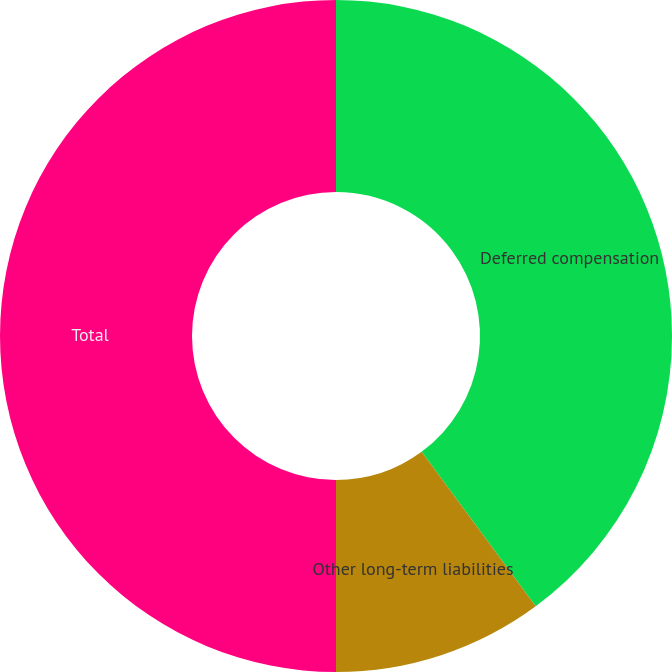Convert chart to OTSL. <chart><loc_0><loc_0><loc_500><loc_500><pie_chart><fcel>Deferred compensation<fcel>Other long-term liabilities<fcel>Total<nl><fcel>39.87%<fcel>10.13%<fcel>50.0%<nl></chart> 